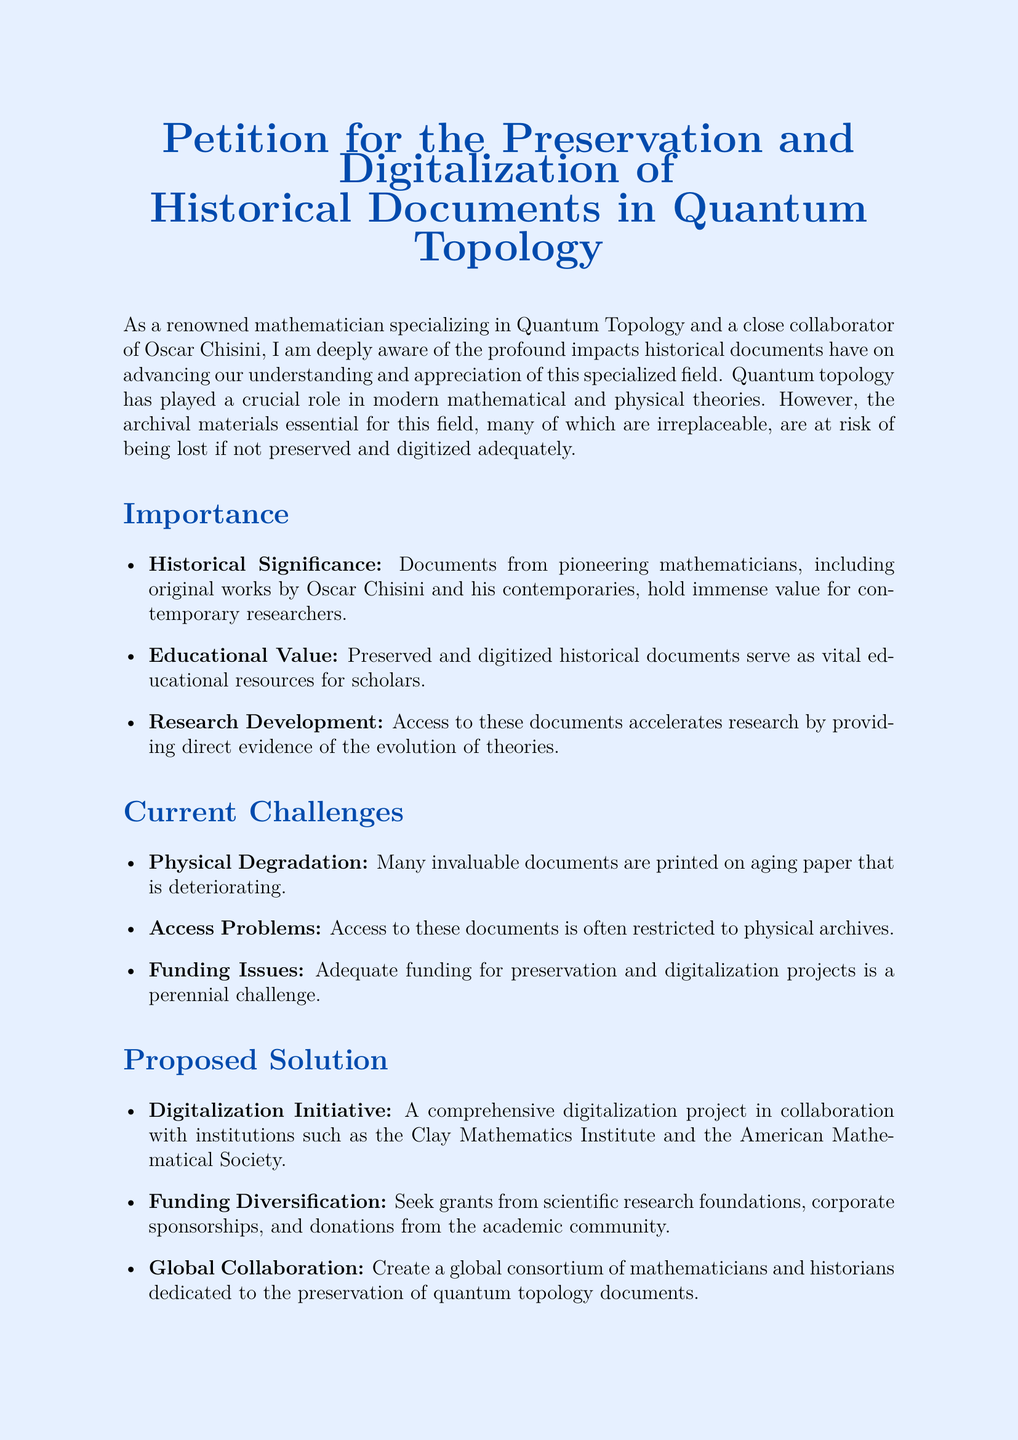What is the title of the petition? The title of the petition is presented at the beginning of the document and addresses the main subject of the document.
Answer: Petition for the Preservation and Digitalization of Historical Documents in Quantum Topology Who is the petition addressed to? The petition does not specify a particular individual or organization but calls on all relevant stakeholders in the mathematical community.
Answer: Fellow mathematicians, academic institutions, research funding bodies What is one of the historical documents mentioned? The petition mentions documents from pioneering mathematicians, specifically noting works by an influential figure in the field.
Answer: Original works by Oscar Chisini What is a proposed solution in the petition? The text outlines initiatives to tackle the challenges mentioned, with specific strategies highlighted in bulleted lists.
Answer: Digitalization Initiative What is one of the current challenges listed in the document? The document describes several challenges faced in preserving the historical documents, focusing on their physical condition and access issues.
Answer: Physical Degradation How does the petitioner suggest funding the initiative? The petition mentions various sources from which financial support could be gained to facilitate the proposed digitalization projects.
Answer: Seek grants from scientific research foundations What kind of collaboration does the petition promote? The initiative stresses the importance of a collaborative effort among different stakeholders to ensure the success of the preservation efforts.
Answer: Global Collaboration What color is used for the section titles? The petition employs a specific color to differentiate section titles and emphasize their importance visually.
Answer: Quantum blue 